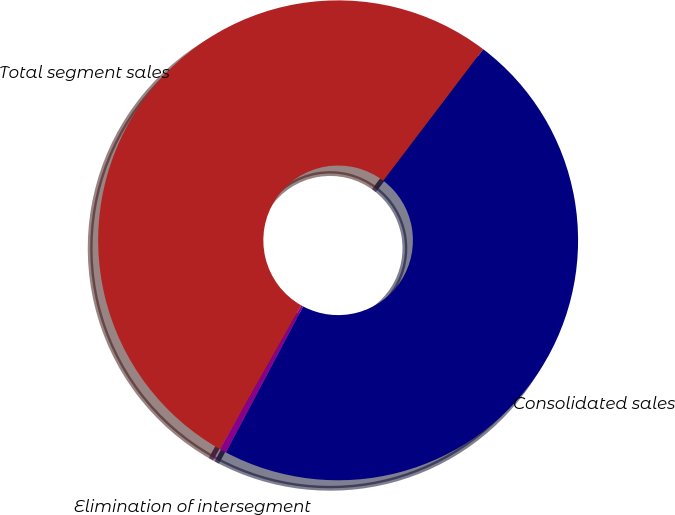<chart> <loc_0><loc_0><loc_500><loc_500><pie_chart><fcel>Total segment sales<fcel>Elimination of intersegment<fcel>Consolidated sales<nl><fcel>52.14%<fcel>0.45%<fcel>47.4%<nl></chart> 